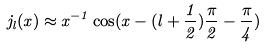<formula> <loc_0><loc_0><loc_500><loc_500>j _ { l } ( x ) \approx x ^ { - 1 } \cos ( x - ( l + \frac { 1 } { 2 } ) \frac { \pi } { 2 } - \frac { \pi } { 4 } )</formula> 